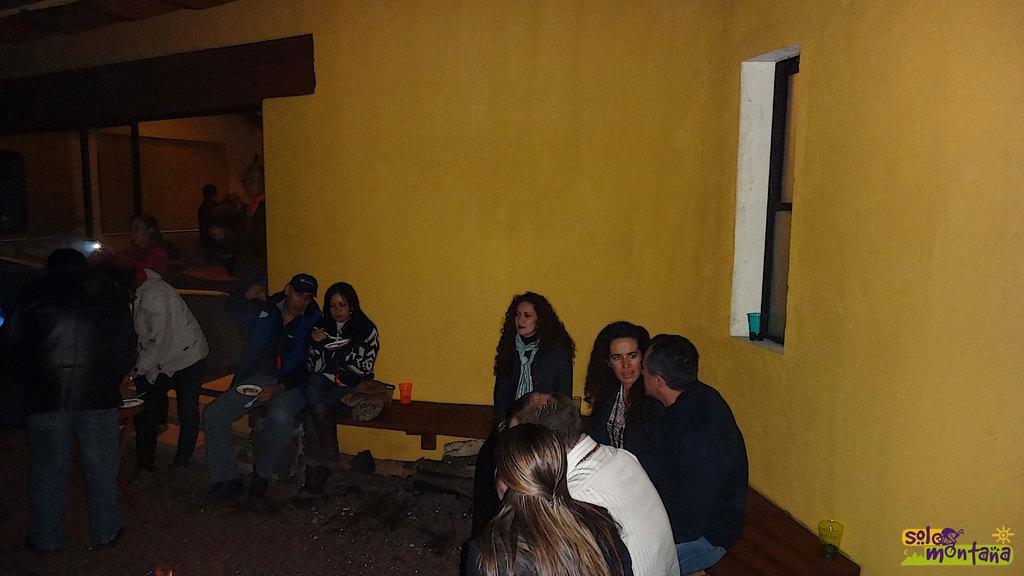In one or two sentences, can you explain what this image depicts? In this image there are a few people sitting on the benches. Beside them there are glasses and a bag. There are a few people standing. There is a table. On top of it there is some object. On the right side of the image there is a glass window. There is a glass on the platform. In the background of the image there is a glass door. There are some text and watermark at the bottom of the image. 